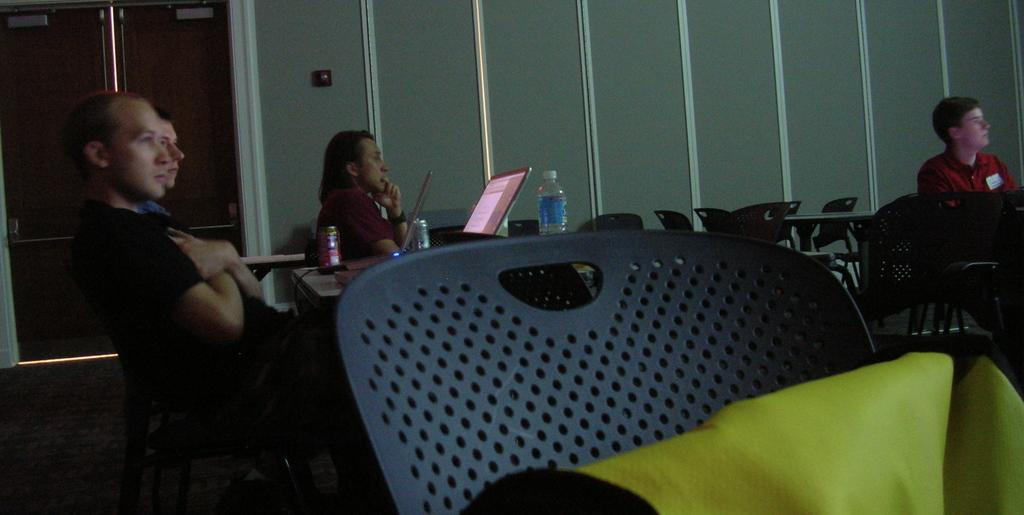How many people are in the image? There are four men in the image. What are the men doing in the image? The men are sitting at tables. What might the men be listening to? The men are listening to something. How much weight can the beginner lift in the image? There is no information about lifting weights or a beginner in the image. 